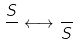<formula> <loc_0><loc_0><loc_500><loc_500>\frac { S } { } \longleftrightarrow \frac { } { S }</formula> 